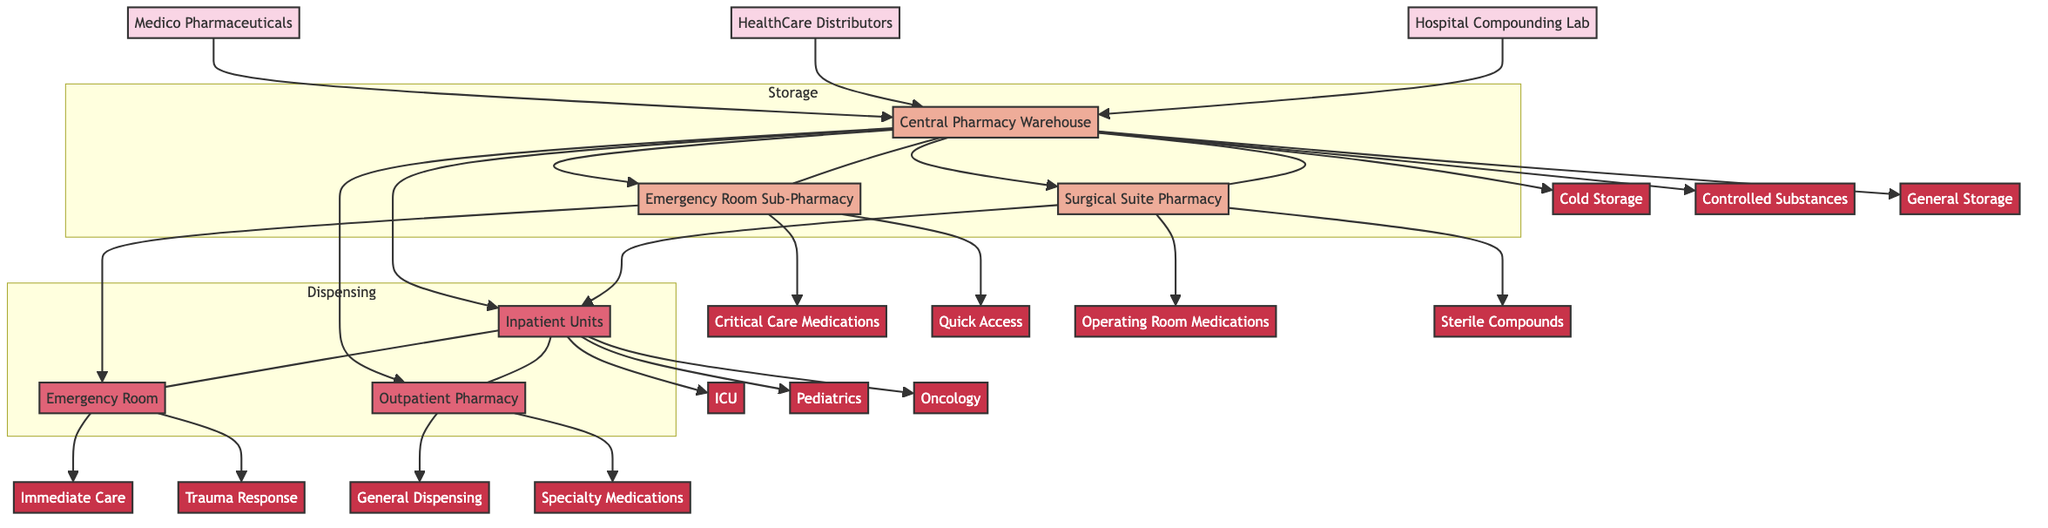What are the two primary suppliers in this diagram? The diagram lists two primary suppliers: Medico Pharmaceuticals and HealthCare Distributors. Both are indicated as sources in the network.
Answer: Medico Pharmaceuticals, HealthCare Distributors How many storage locations are shown in the diagram? There are three storage locations identified in the diagram: Central Pharmacy Warehouse, Emergency Room Sub-Pharmacy, and Surgical Suite Pharmacy. This can be counted directly from the diagram.
Answer: 3 Which storage location has a large capacity? The Central Pharmacy Warehouse is identified as having a large capacity, while the other two have medium and small capacities. This information can be deduced from the storage locations.
Answer: Central Pharmacy Warehouse What specific units are part of the Inpatient Units dispensing point? The Inpatient Units dispensing point includes specific units such as ICU, Pediatrics, and Oncology, as indicated in the diagram.
Answer: ICU, Pediatrics, Oncology What type of products does the Hospital Compounding Lab produce? The Hospital Compounding Lab is indicated in the diagram to produce Custom IV Mixes and Patient-Specific Dosages, which are listed under internal production.
Answer: Custom IV Mixes, Patient-Specific Dosages Which storage location provides Critical Care Medications? The Emergency Room Sub-Pharmacy is responsible for dispensing Critical Care Medications as shown in the sections included under this storage location in the diagram.
Answer: Emergency Room Sub-Pharmacy How are the medical suppliers connected to the storage locations? The medical suppliers Medico Pharmaceuticals and HealthCare Distributors connect to the Central Pharmacy Warehouse, indicating that they provide medications which are stored there before distribution to other locations.
Answer: Central Pharmacy Warehouse How many specific units are in the Outpatient Pharmacy? The Outpatient Pharmacy has two specific units mentioned: General Dispensing and Specialty Medications, which can be directly referenced from the dispensing points in the diagram.
Answer: 2 